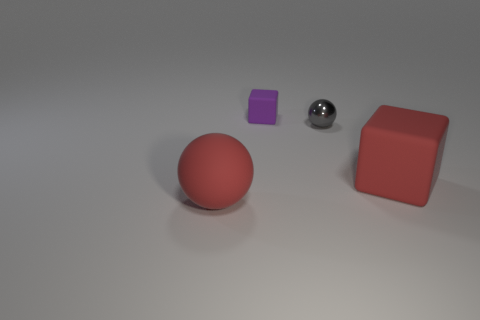How do the shadows in the image indicate the light source position? The shadows of the objects are cast towards the bottom right corner of the image, suggesting that the light source is positioned to the top left of the scene, outside of the frame. 